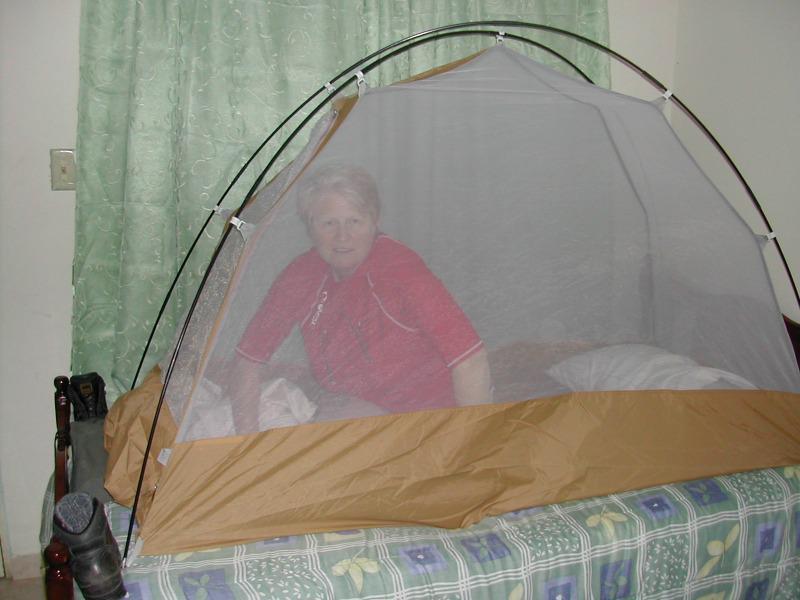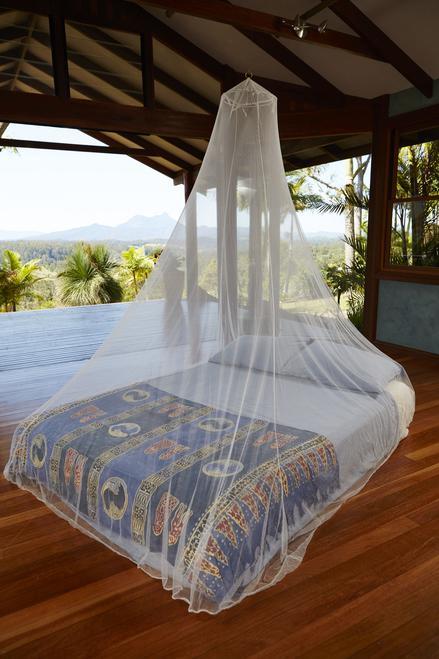The first image is the image on the left, the second image is the image on the right. Examine the images to the left and right. Is the description "The netting in the image on the left is suspended from its corners." accurate? Answer yes or no. No. 